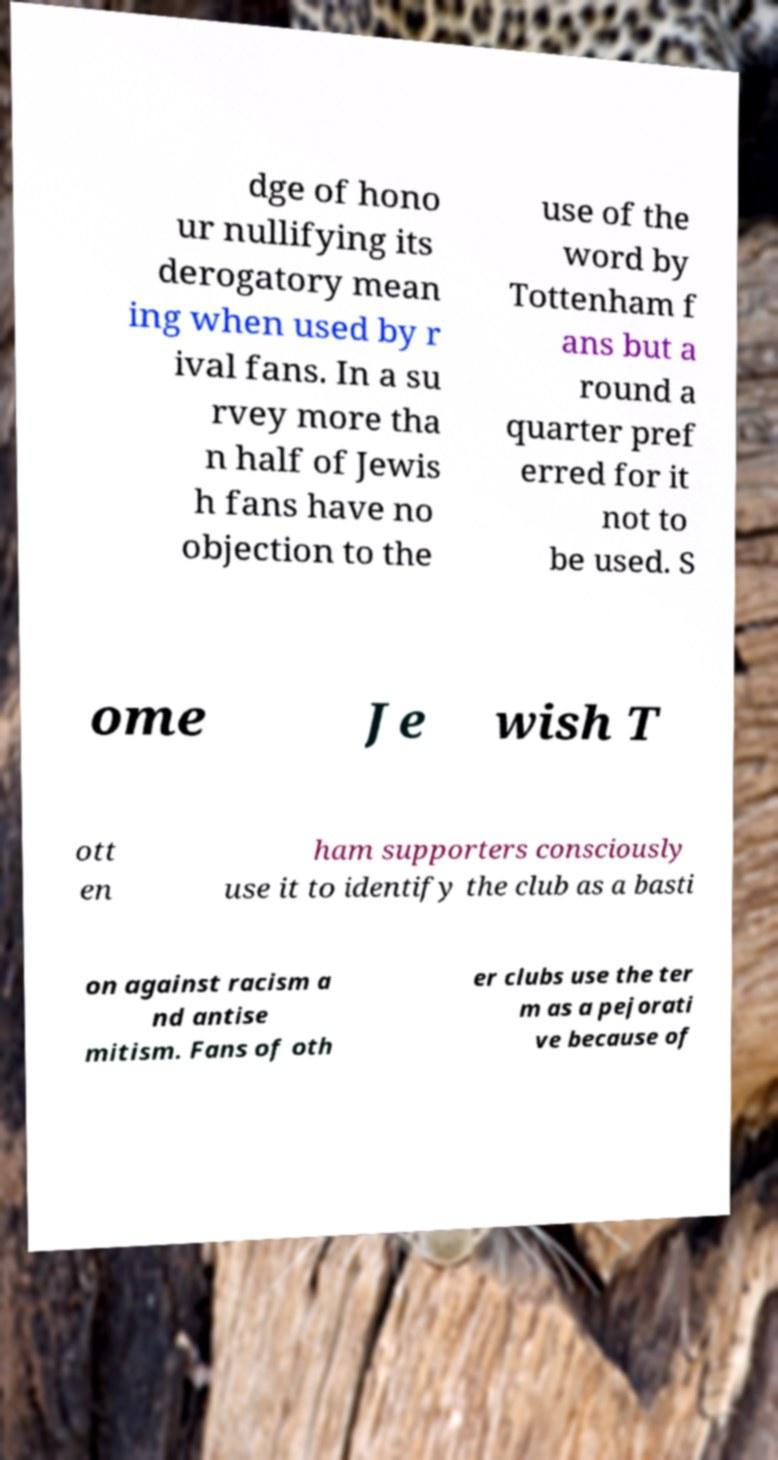There's text embedded in this image that I need extracted. Can you transcribe it verbatim? dge of hono ur nullifying its derogatory mean ing when used by r ival fans. In a su rvey more tha n half of Jewis h fans have no objection to the use of the word by Tottenham f ans but a round a quarter pref erred for it not to be used. S ome Je wish T ott en ham supporters consciously use it to identify the club as a basti on against racism a nd antise mitism. Fans of oth er clubs use the ter m as a pejorati ve because of 